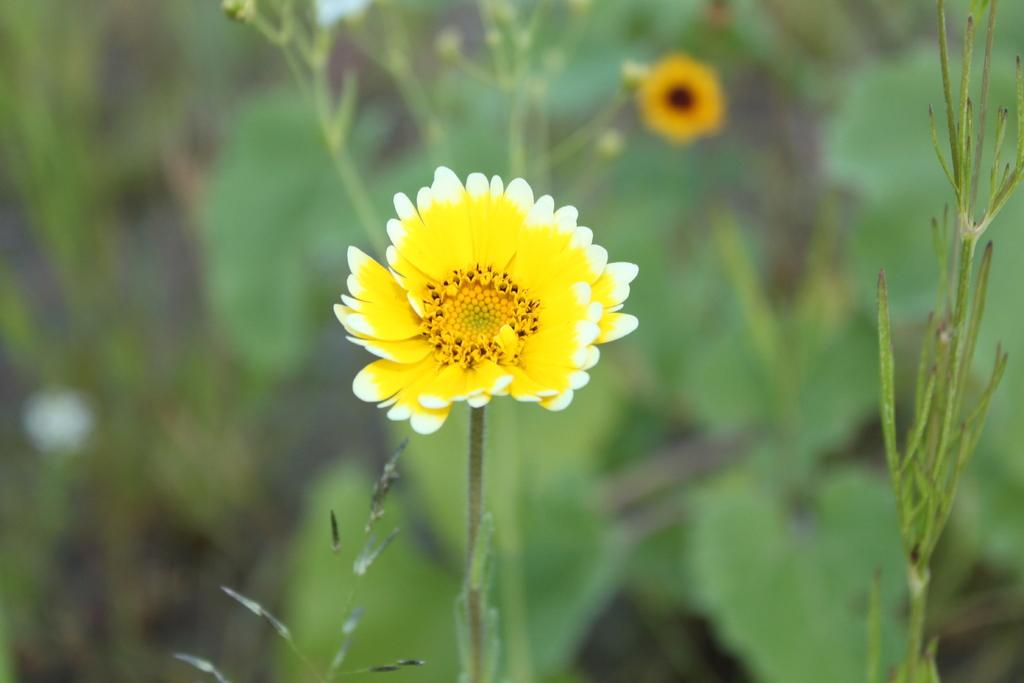What type of plant is visible in the image? There is a flower in a plant visible in the image. Can you describe the surrounding plants in the image? There are other plants visible behind the flower, but they are not clearly visible. Is there a bridge visible in the image? No, there is no bridge present in the image. Can you see a stream flowing through the plants in the image? No, there is no stream visible in the image. 